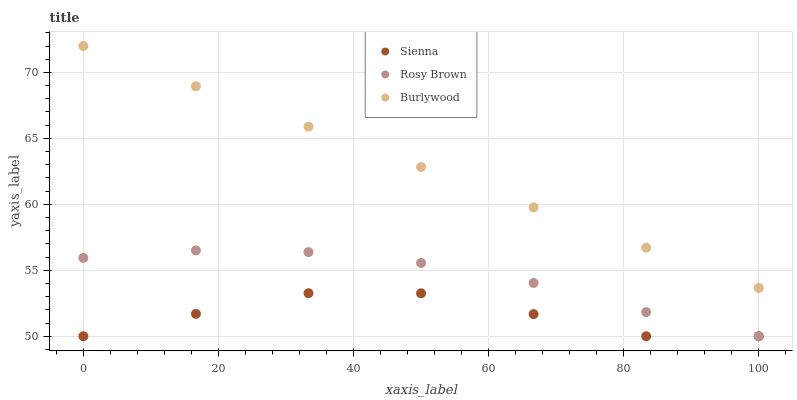Does Sienna have the minimum area under the curve?
Answer yes or no. Yes. Does Burlywood have the maximum area under the curve?
Answer yes or no. Yes. Does Rosy Brown have the minimum area under the curve?
Answer yes or no. No. Does Rosy Brown have the maximum area under the curve?
Answer yes or no. No. Is Burlywood the smoothest?
Answer yes or no. Yes. Is Sienna the roughest?
Answer yes or no. Yes. Is Rosy Brown the smoothest?
Answer yes or no. No. Is Rosy Brown the roughest?
Answer yes or no. No. Does Sienna have the lowest value?
Answer yes or no. Yes. Does Burlywood have the lowest value?
Answer yes or no. No. Does Burlywood have the highest value?
Answer yes or no. Yes. Does Rosy Brown have the highest value?
Answer yes or no. No. Is Rosy Brown less than Burlywood?
Answer yes or no. Yes. Is Burlywood greater than Rosy Brown?
Answer yes or no. Yes. Does Sienna intersect Rosy Brown?
Answer yes or no. Yes. Is Sienna less than Rosy Brown?
Answer yes or no. No. Is Sienna greater than Rosy Brown?
Answer yes or no. No. Does Rosy Brown intersect Burlywood?
Answer yes or no. No. 